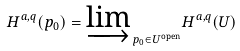Convert formula to latex. <formula><loc_0><loc_0><loc_500><loc_500>H ^ { a , q } ( p _ { 0 } ) = { \varinjlim } _ { \, p _ { 0 } \in { U } ^ { \text {open} } } H ^ { a , q } ( U )</formula> 